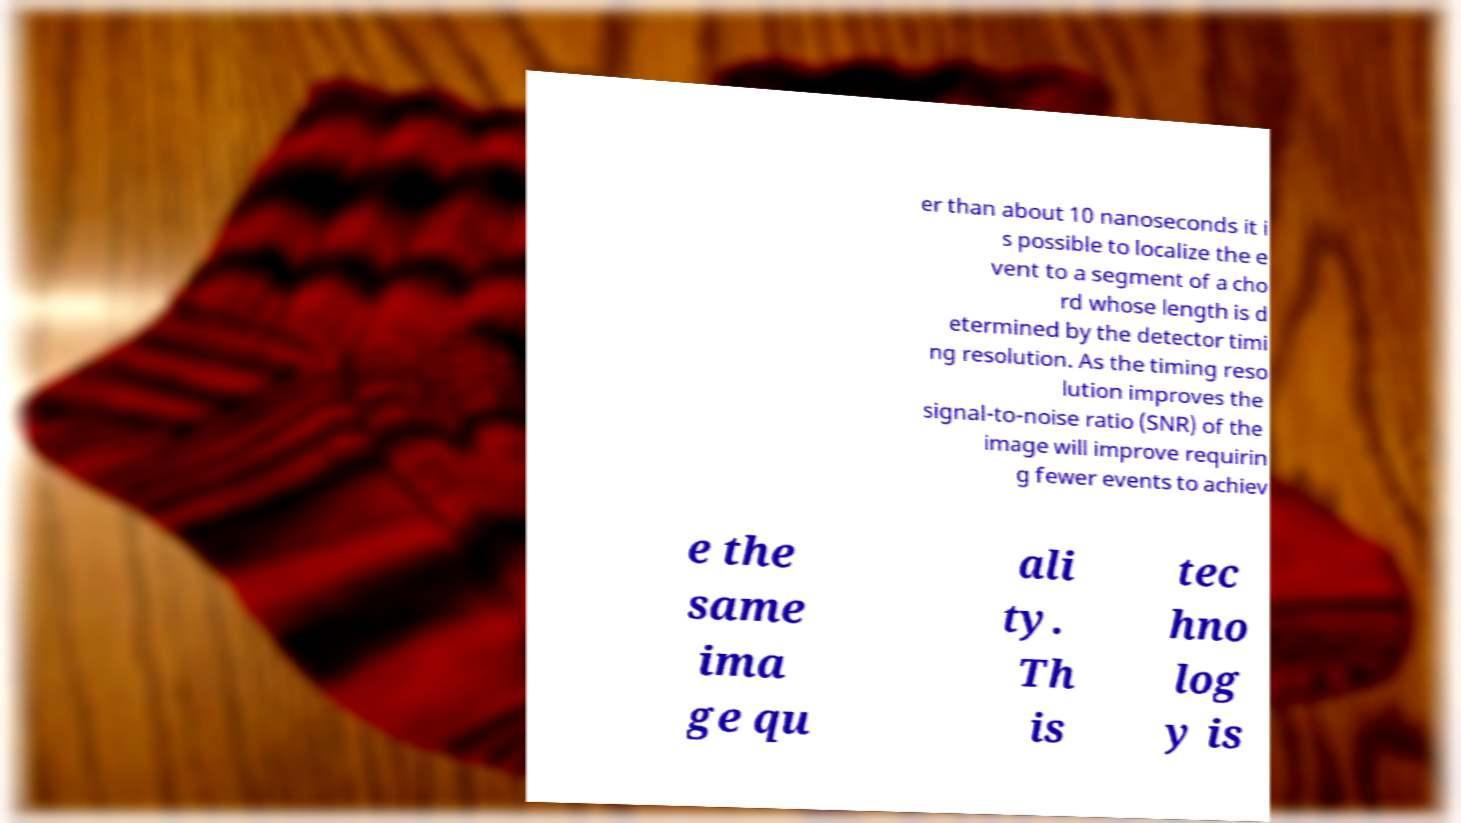I need the written content from this picture converted into text. Can you do that? er than about 10 nanoseconds it i s possible to localize the e vent to a segment of a cho rd whose length is d etermined by the detector timi ng resolution. As the timing reso lution improves the signal-to-noise ratio (SNR) of the image will improve requirin g fewer events to achiev e the same ima ge qu ali ty. Th is tec hno log y is 